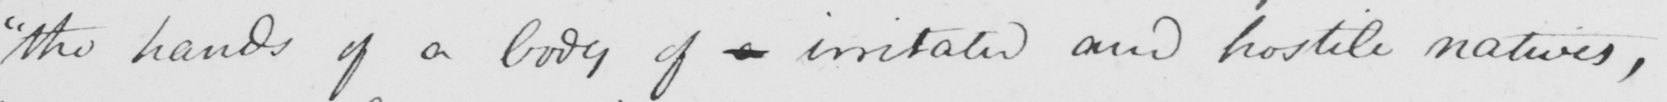Please provide the text content of this handwritten line. " the hands of a body of a irritated and hostile natives , 